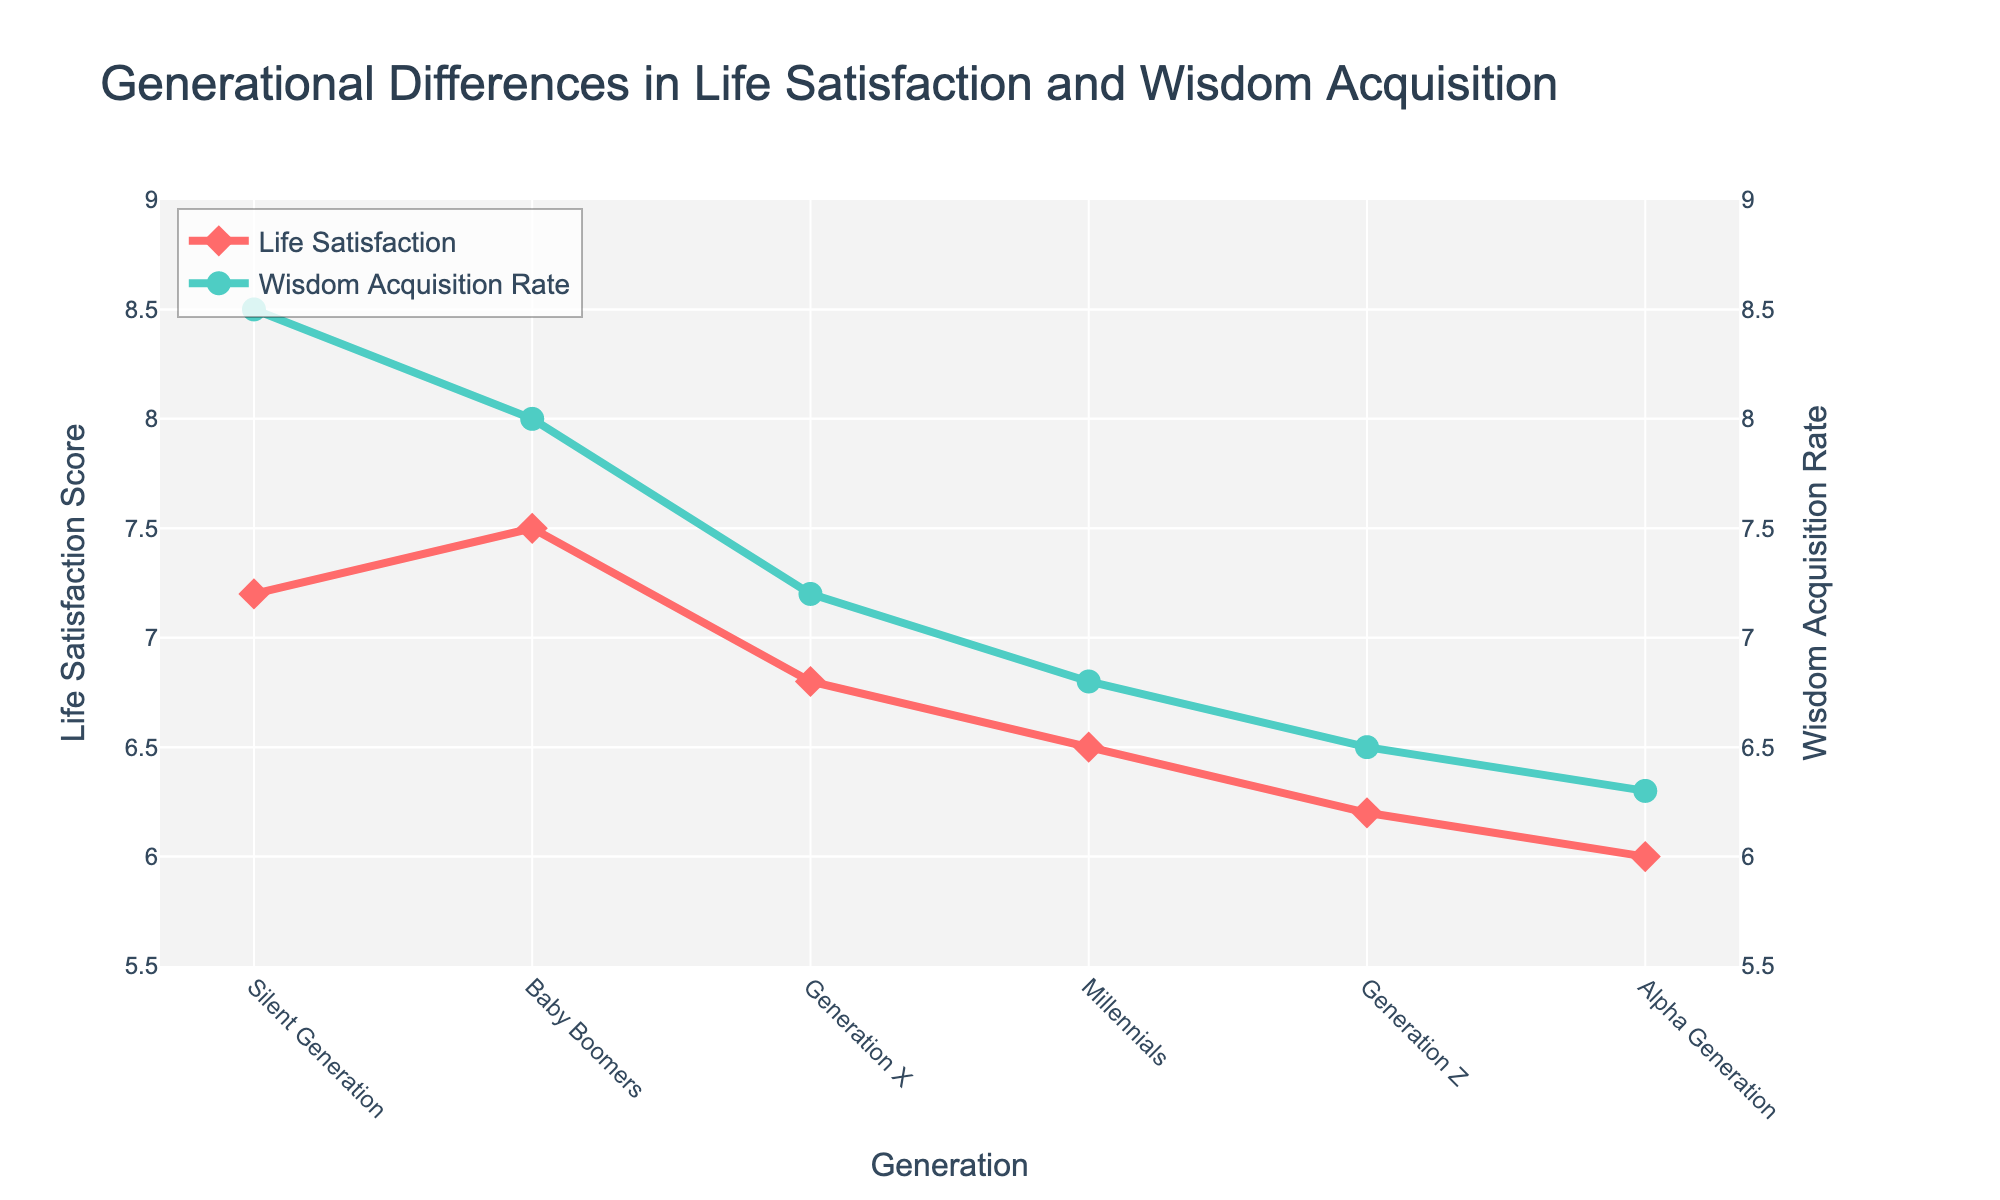What is the trend in Life Satisfaction from the Silent Generation to the Alpha Generation? The trend in Life Satisfaction scores decreases from the Silent Generation to the Alpha Generation. The Silent Generation starts at 7.2 and gradually decreases to 6.0 in the Alpha Generation.
Answer: Decreasing Which generation has the highest Wisdom Acquisition Rate? To identify the generation with the highest Wisdom Acquisition Rate, we look at the highest point on the Wisdom Acquisition line. The Silent Generation has the highest rate at 8.5.
Answer: Silent Generation How does the Wisdom Acquisition Rate of Generation X compare to Millennials? By comparing the points on the Wisdom Acquisition Rate line, we see that Generation X has a rate of 7.2, while Millennials have a rate of 6.8. Therefore, Generation X has a higher rate.
Answer: Generation X has a higher rate What is the average Life Satisfaction score for Baby Boomers and Generation Z? Calculate the average by summing the Life Satisfaction scores of Baby Boomers (7.5) and Generation Z (6.2) and then dividing by 2. (7.5 + 6.2) / 2 = 6.85.
Answer: 6.85 Which generation shows the smallest difference between Life Satisfaction and Wisdom Acquisition Rate? Calculate the difference between Life Satisfaction and Wisdom Acquisition Rate for each generation. The generation with the smallest absolute difference is Baby Boomers, with a difference of
Answer: Baby Boomers What are the Life Satisfaction and Wisdom Acquisition Rates for Millennials? The Life Satisfaction score for Millennials is 6.5, and the Wisdom Acquisition Rate is 6.8. These can be extracted by looking at the respective points on the plot for Millennials.
Answer: Life Satisfaction: 6.5, Wisdom Acquisition Rate: 6.8 Is the Wisdom Acquisition Rate for Alpha Generation higher than that of Generation Z? Compare the rates: Alpha Generation has a rate of 6.3, while Generation Z has a rate of 6.5. Therefore, the Wisdom Acquisition Rate for Alpha Generation is lower.
Answer: No, it is not higher What is the visual difference between the Life Satisfaction line and the Wisdom Acquisition Rate line? The Life Satisfaction line is represented in red with diamond markers, and the Wisdom Acquisition Rate line is in green with circle markers. These visual distinctions help differentiate the two metrics.
Answer: One is red with diamonds, the other is green with circles What is the increase in Wisdom Acquisition Rate from Millennials to Generation X? To find the increase, subtract the Wisdom Acquisition Rate of Millennials (6.8) from Generation X (7.2). 7.2 - 6.8 = 0.4.
Answer: 0.4 How much greater is Baby Boomers' Life Satisfaction compared to Generation Z's? Subtract Generation Z's Life Satisfaction (6.2) from Baby Boomers' (7.5). 7.5 - 6.2 = 1.3.
Answer: 1.3 